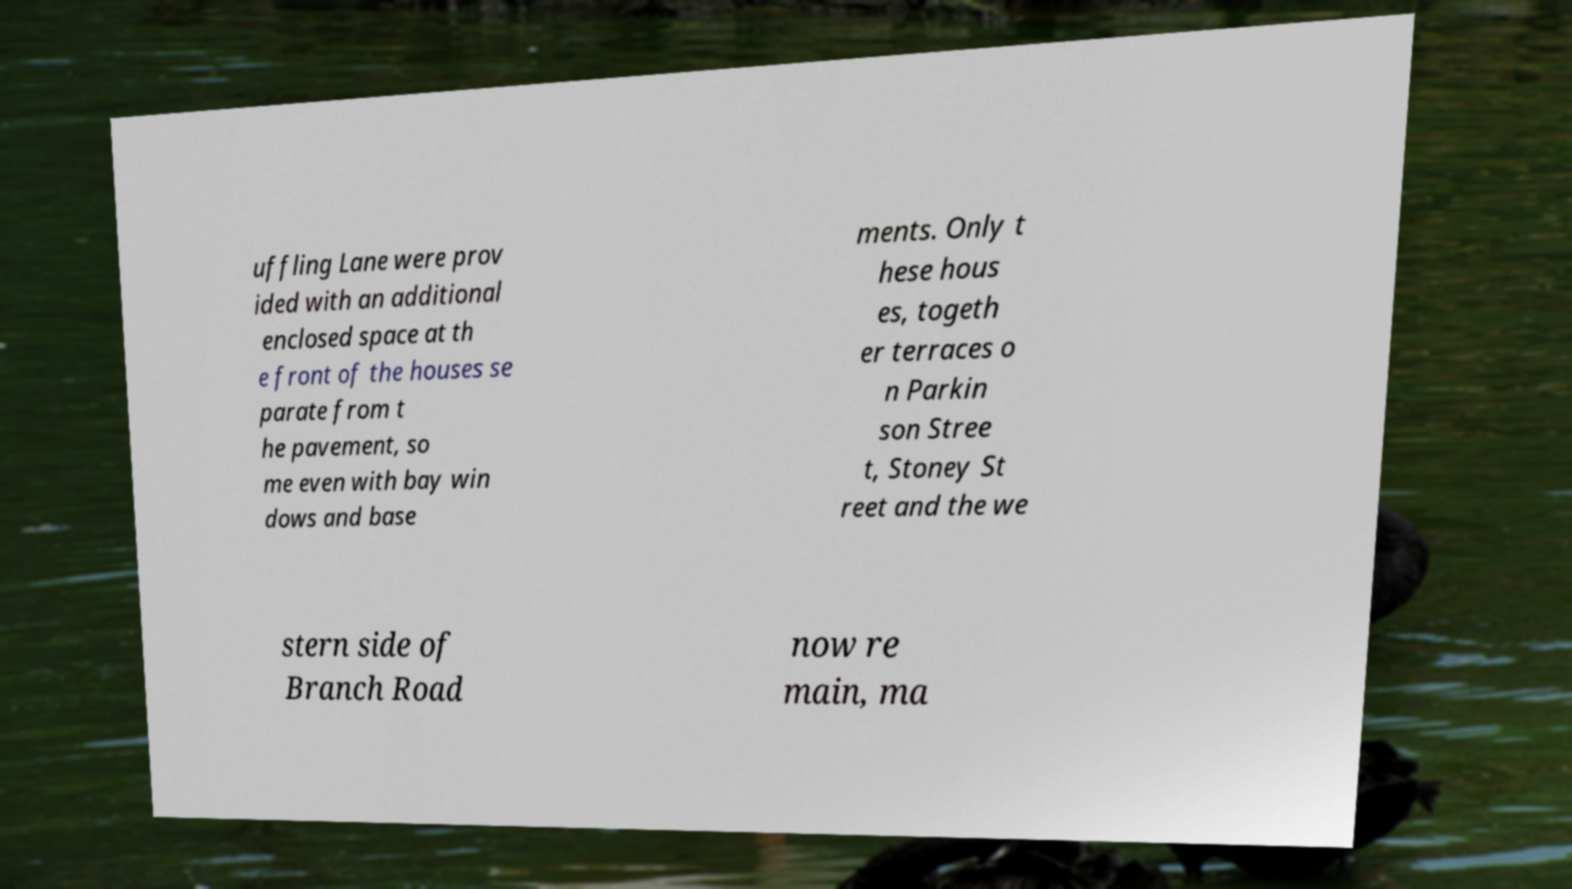Can you read and provide the text displayed in the image?This photo seems to have some interesting text. Can you extract and type it out for me? uffling Lane were prov ided with an additional enclosed space at th e front of the houses se parate from t he pavement, so me even with bay win dows and base ments. Only t hese hous es, togeth er terraces o n Parkin son Stree t, Stoney St reet and the we stern side of Branch Road now re main, ma 